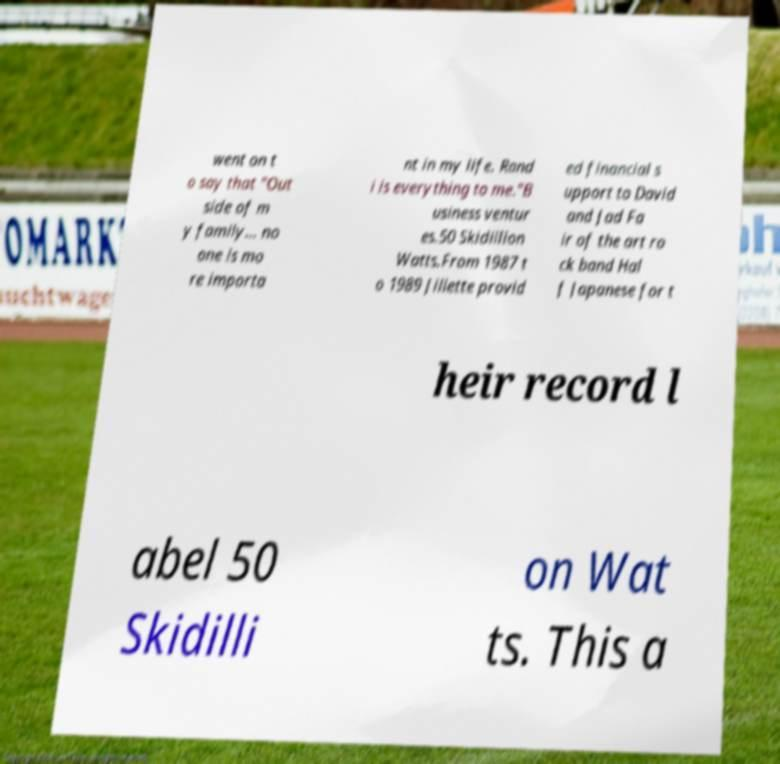Could you assist in decoding the text presented in this image and type it out clearly? went on t o say that "Out side of m y family... no one is mo re importa nt in my life. Rand i is everything to me."B usiness ventur es.50 Skidillion Watts.From 1987 t o 1989 Jillette provid ed financial s upport to David and Jad Fa ir of the art ro ck band Hal f Japanese for t heir record l abel 50 Skidilli on Wat ts. This a 